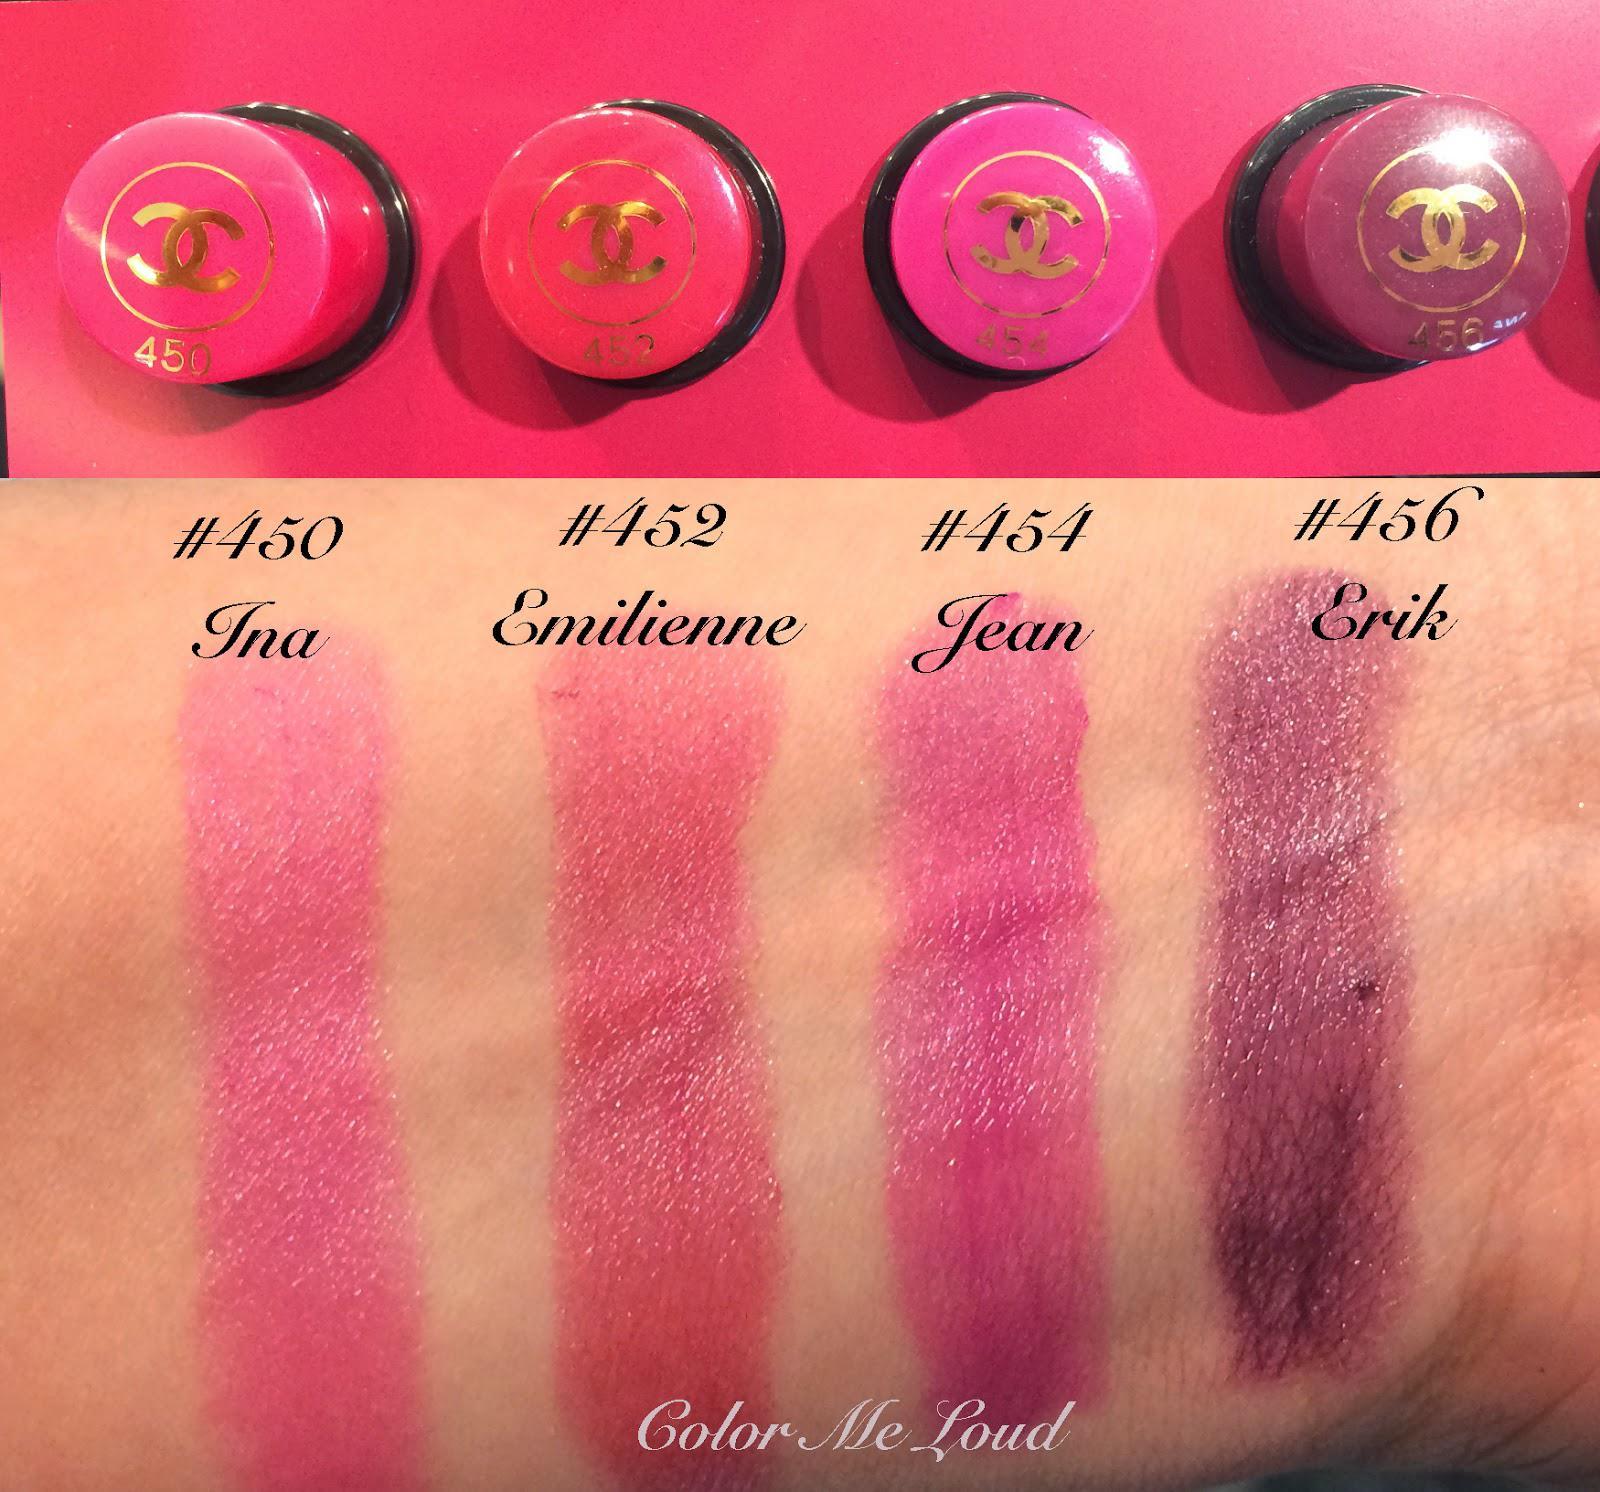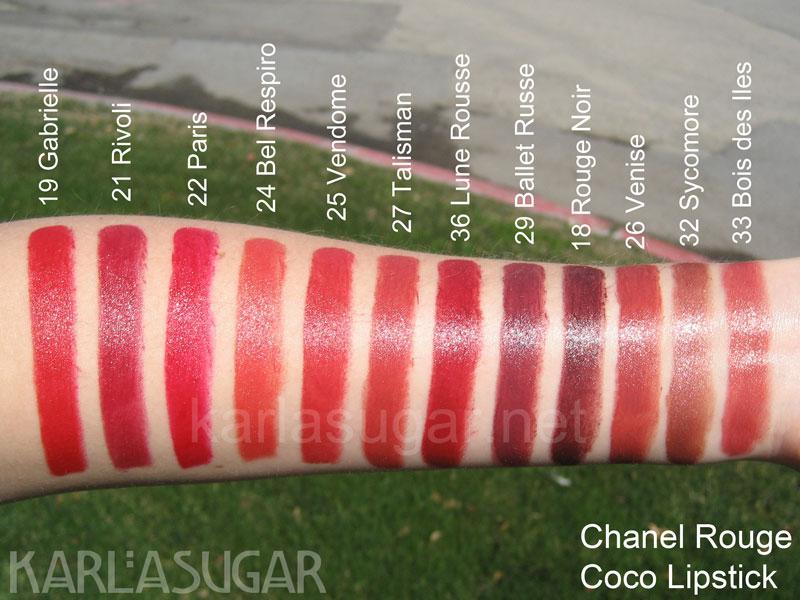The first image is the image on the left, the second image is the image on the right. Analyze the images presented: Is the assertion "An image shows a row of lipstick pots above a row of lipstick streaks on human skin." valid? Answer yes or no. Yes. The first image is the image on the left, the second image is the image on the right. Examine the images to the left and right. Is the description "Differebt shades of lip stick are shoen on aerial view and above lipstick shades shown on human skin." accurate? Answer yes or no. Yes. 